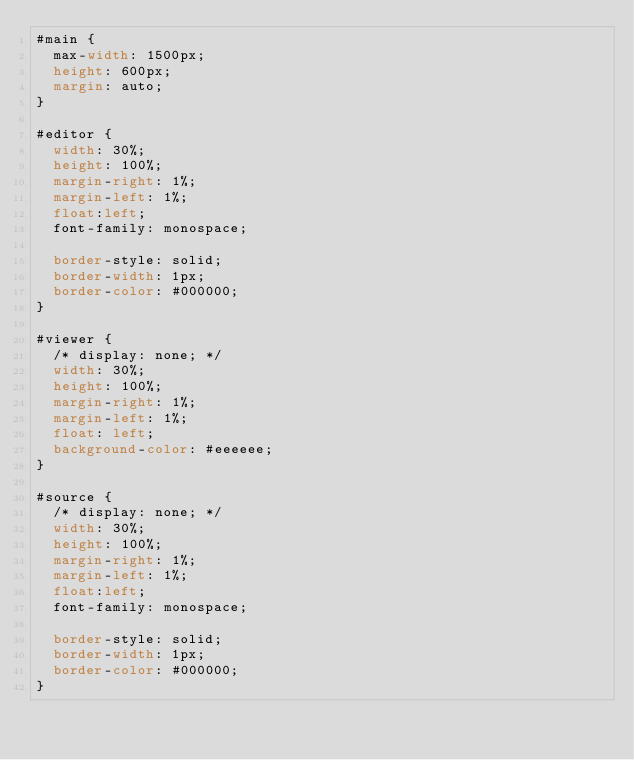<code> <loc_0><loc_0><loc_500><loc_500><_CSS_>#main {
	max-width: 1500px;
	height: 600px;
	margin: auto;
}

#editor {
	width: 30%;
	height: 100%;
	margin-right: 1%;
	margin-left: 1%;
	float:left;
	font-family: monospace; 

	border-style: solid;
	border-width: 1px;
	border-color: #000000;
}

#viewer {
	/* display: none; */
	width: 30%;
	height: 100%;
	margin-right: 1%;
	margin-left: 1%;
	float: left;
	background-color: #eeeeee;
}

#source {
	/* display: none; */
	width: 30%;
	height: 100%;
	margin-right: 1%;
	margin-left: 1%;
	float:left;
	font-family: monospace; 

	border-style: solid;
	border-width: 1px;
	border-color: #000000;
}
</code> 